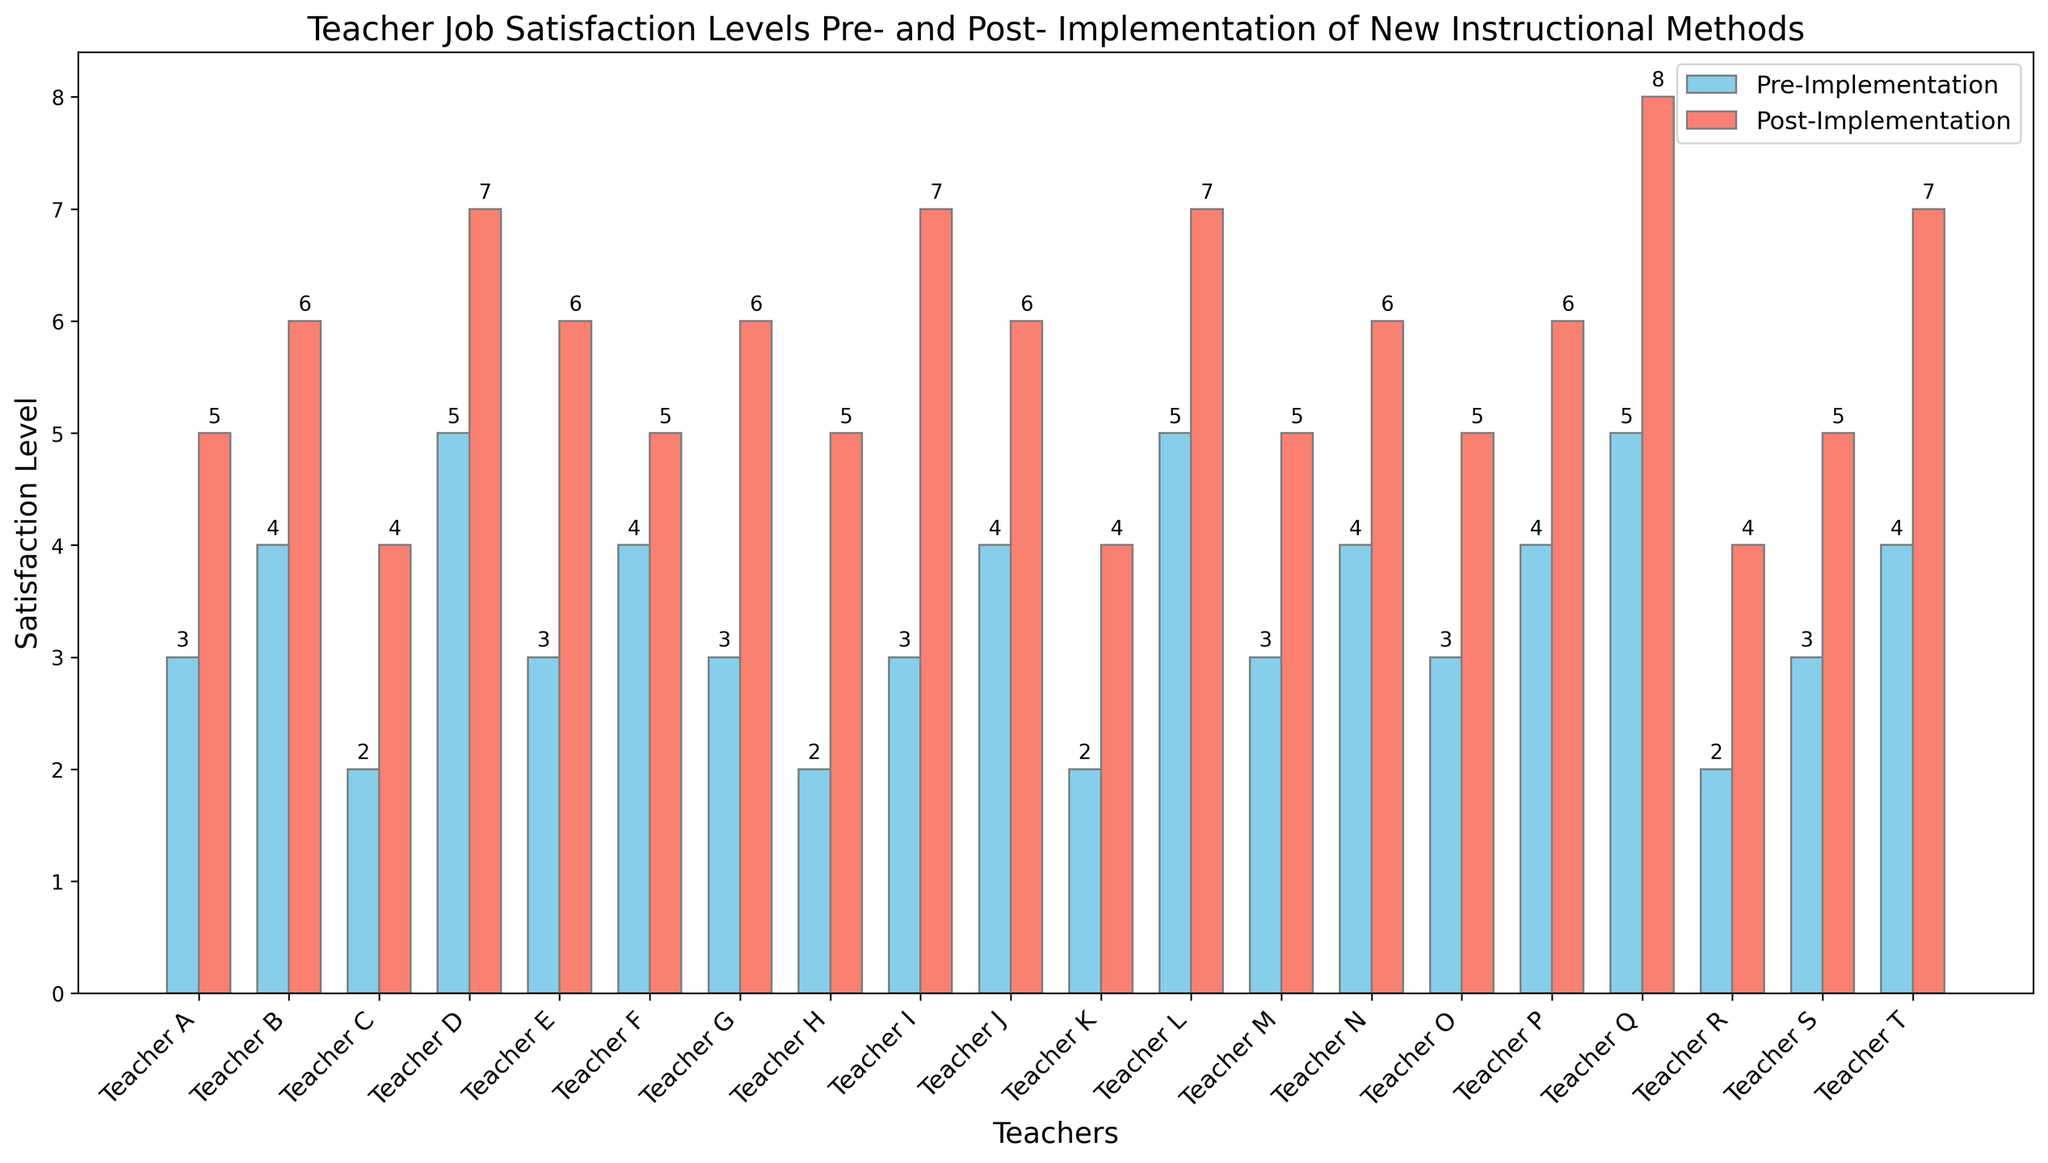What is the average pre-implementation satisfaction level? Sum the pre-implementation satisfaction levels: (3 + 4 + 2 + 5 + 3 + 4 + 3 + 2 + 3 + 4 + 2 + 5 + 3 + 4 + 3 + 4 + 5 + 2 + 3 + 4) = 70. Divide by the number of teachers (20): 70 / 20 = 3.5
Answer: 3.5 Which teacher had the highest post-implementation satisfaction level? Look for the tallest bar in the post-implementation group (salmon-colored). Teacher Q has a height of 8, the highest among all.
Answer: Teacher Q By how much did the average satisfaction level increase from pre- to post-implementation? Calculate the average pre-implementation satisfaction level: 70 / 20 = 3.5. Calculate the average post-implementation satisfaction level: (5 + 6 + 4 + 7 + 6 + 5 + 6 + 5 + 7 + 6 + 4 + 7 + 5 + 6 + 5 + 6 + 8 + 4 + 5 + 7) = 113 / 20 = 5.65. The difference is 5.65 - 3.5.
Answer: 2.15 Which teacher showed the least improvement in satisfaction level? Calculate the difference between the post- and pre-implementation satisfaction levels for each teacher. Teacher F has the smallest improvement (5 - 4 = 1).
Answer: Teacher F How many teachers had a pre-implementation satisfaction level of less than 3? Count the number of teachers with a pre-implementation satisfaction level of less than 3. Teachers C, H, K, and R have levels of 2.
Answer: 4 Which group (pre- or post-implementation) had more teachers with a satisfaction level of 5 or higher? Count the number of teachers with satisfaction levels of 5 or higher for both groups. Pre-implementation: Teachers D, L, and Q (3 teachers). Post-implementation: Teachers A, D, E, G, I, L, N, P, Q, and T (10 teachers).
Answer: Post-implementation Which teacher experienced the highest increase in satisfaction level? Calculate the differences between the post- and pre-implementation levels for each teacher. Teacher Q had an increase of 3 (8 - 5).
Answer: Teacher Q How many teachers had an increase of at least 2 levels in satisfaction? Calculate the differences between the post- and pre-implementation levels for each teacher. Teachers A, B, C, E, G, H, I, J, K, L, N, P, Q, S, T experienced at least a 2-level increase.
Answer: 15 